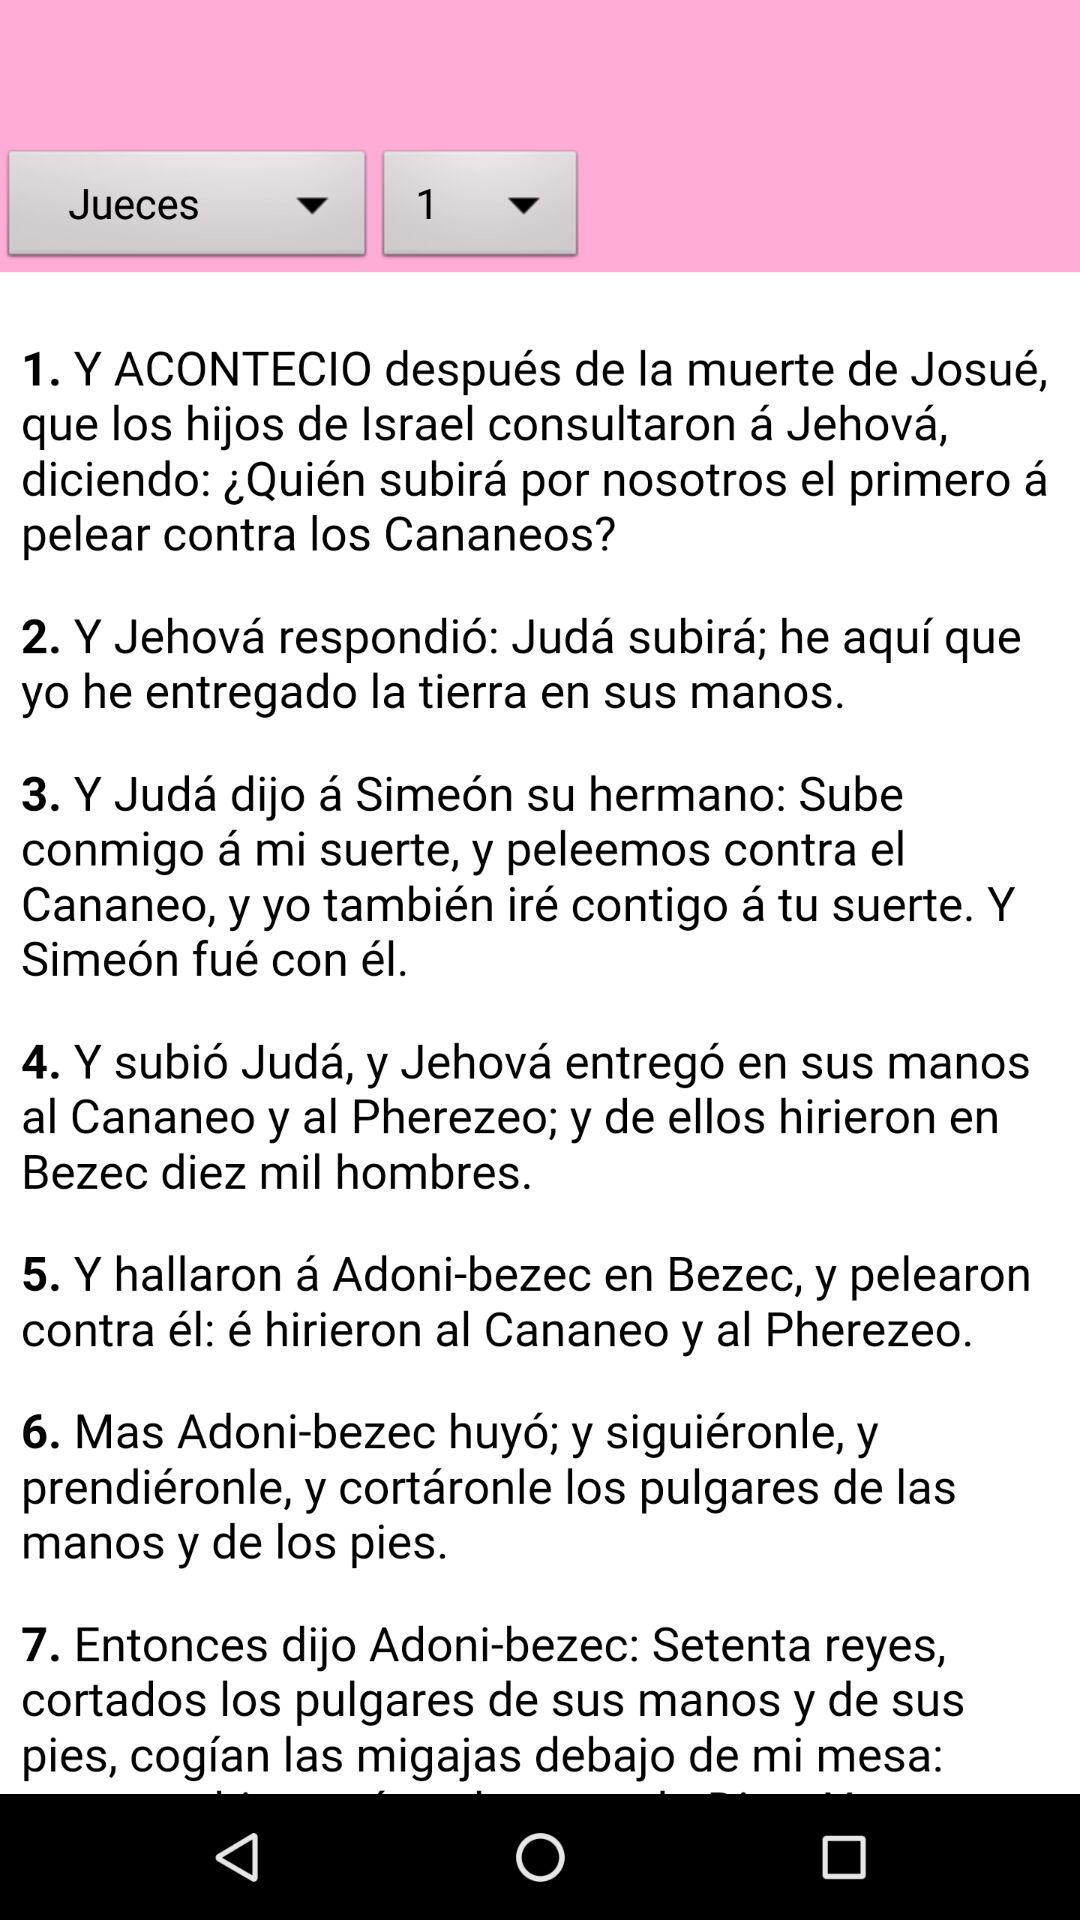How many verses are there in the passage?
Answer the question using a single word or phrase. 7 